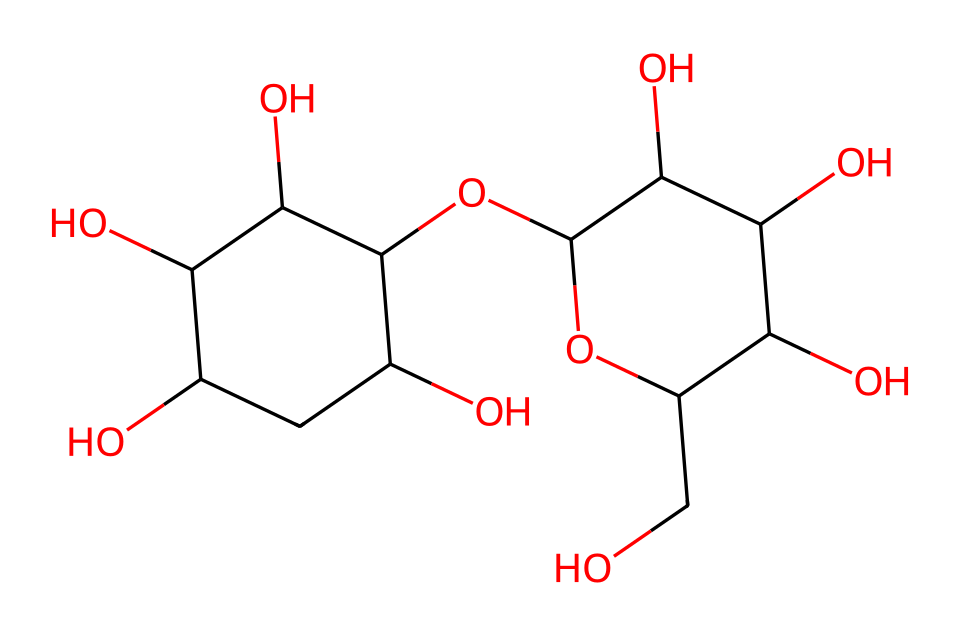What is the main component of this chemical structure? The chemical structure corresponds to cornstarch, which is primarily composed of amylose and amylopectin, two polysaccharides found in corn kernels.
Answer: cornstarch How many oxygen atoms are present in this chemical structure? By analyzing the SMILES representation, we can count the number of 'O' letters, which represent oxygen atoms; there are six oxygen atoms in total.
Answer: six What kind of interactions can cornstarch exhibit in a non-Newtonian fluid? In a non-Newtonian fluid, cornstarch exhibits shear-thickening behavior, meaning it becomes more viscous when stressed or stirred, due to its molecular structure and interactions between starch molecules.
Answer: shear-thickening What is the role of water in the non-Newtonian fluid made from cornstarch? Water acts as a solvent that hydrates the cornstarch molecules, allowing them to swell and create a network that influences the fluid's viscosity and behavior under stress.
Answer: solvent Why does cornstarch create a non-Newtonian fluid when mixed with water? The unique arrangement of amylose and amylopectin in cornstarch influences the interactions between molecules under shear stress, causing the fluid to change viscosity dramatically.
Answer: viscosity change How does the structure of cornstarch influence its properties in special effects? The specific branching and arrangement of amylopectin molecules provide cornstarch with unique properties, such as resilience and the ability to mimic solids under impact, suitable for special effects in films.
Answer: resilience 